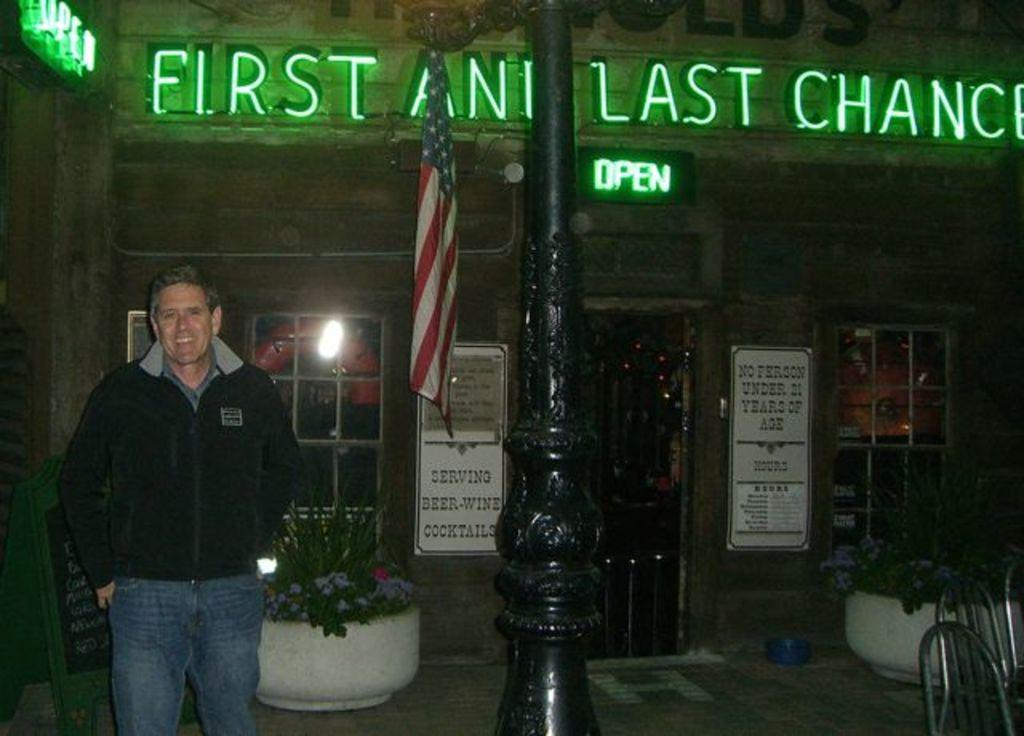What is the main subject of the image? There is a person standing in the image. Where is the person standing? The person is standing on the ground. What can be seen in the background of the image? There are houseplants, windows, a flagpole, and name boards in the background of the image. What type of marble is being used to attack the person in the image? There is no marble or attack present in the image; it features a person standing on the ground with various background elements. 